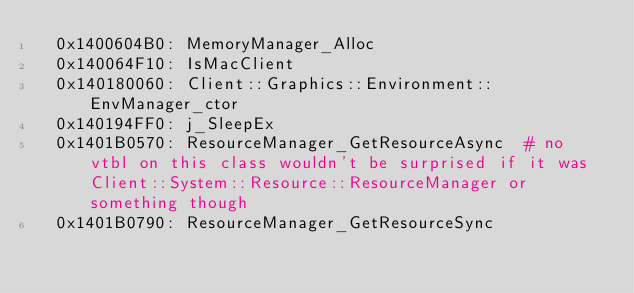Convert code to text. <code><loc_0><loc_0><loc_500><loc_500><_YAML_>  0x1400604B0: MemoryManager_Alloc
  0x140064F10: IsMacClient
  0x140180060: Client::Graphics::Environment::EnvManager_ctor
  0x140194FF0: j_SleepEx
  0x1401B0570: ResourceManager_GetResourceAsync  # no vtbl on this class wouldn't be surprised if it was Client::System::Resource::ResourceManager or something though
  0x1401B0790: ResourceManager_GetResourceSync</code> 